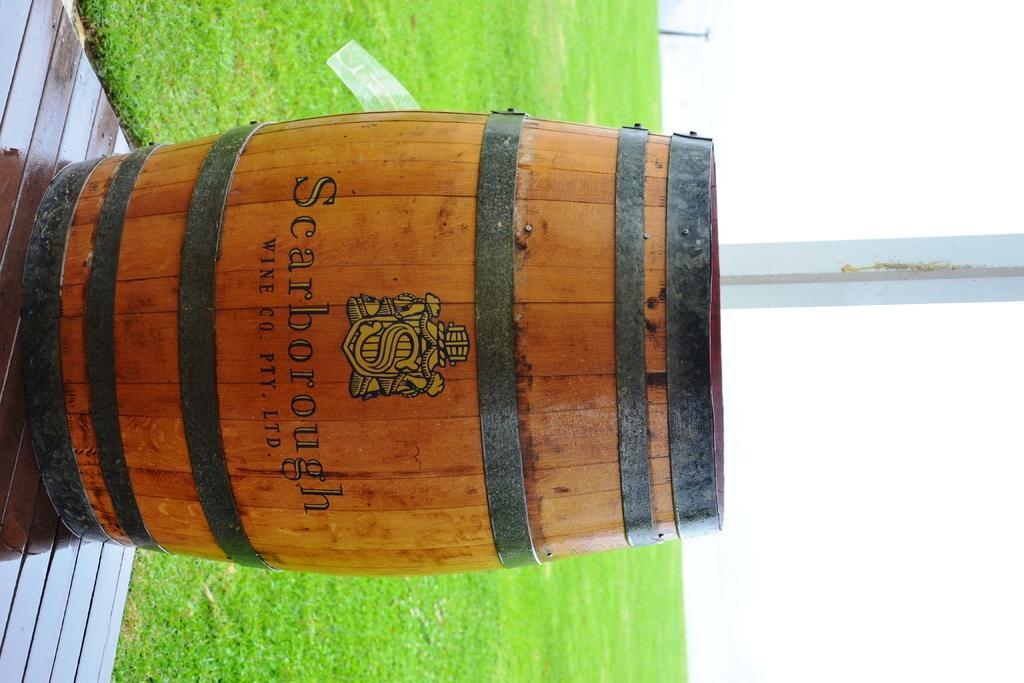Could you give a brief overview of what you see in this image? In the image we can see there is a wooden drum kept on the floor and behind there is grass on the ground. There is a clear sky. 